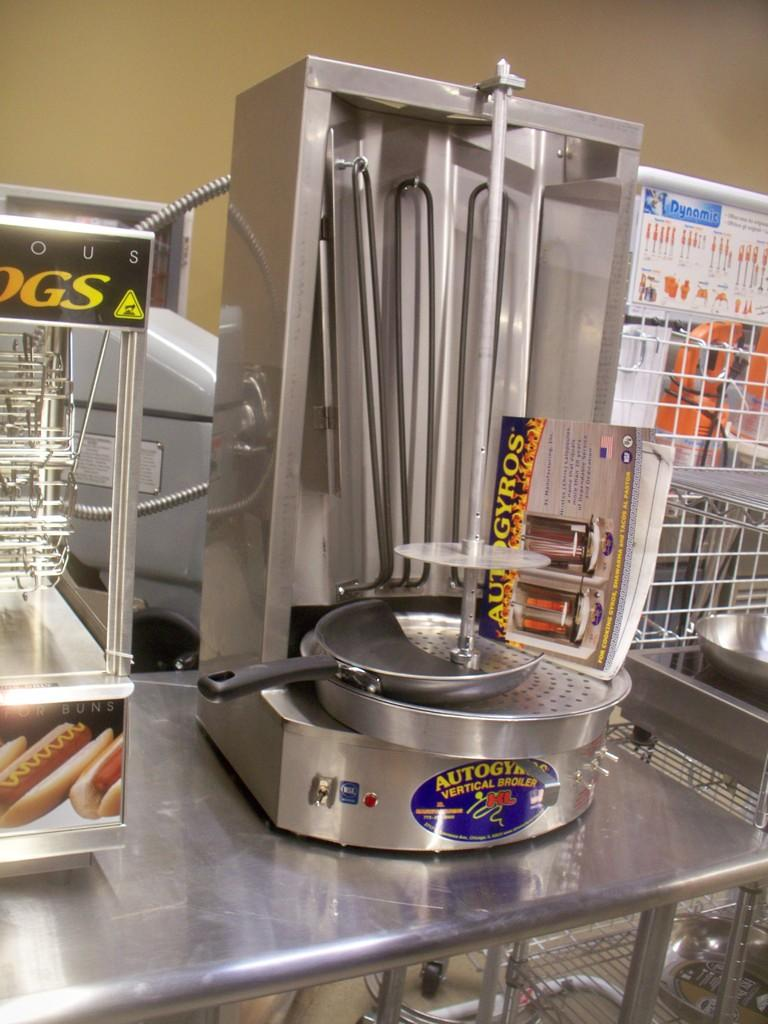<image>
Summarize the visual content of the image. A stainless steel kitchen gadget that says "Autogyros vertical broiler" on it. 